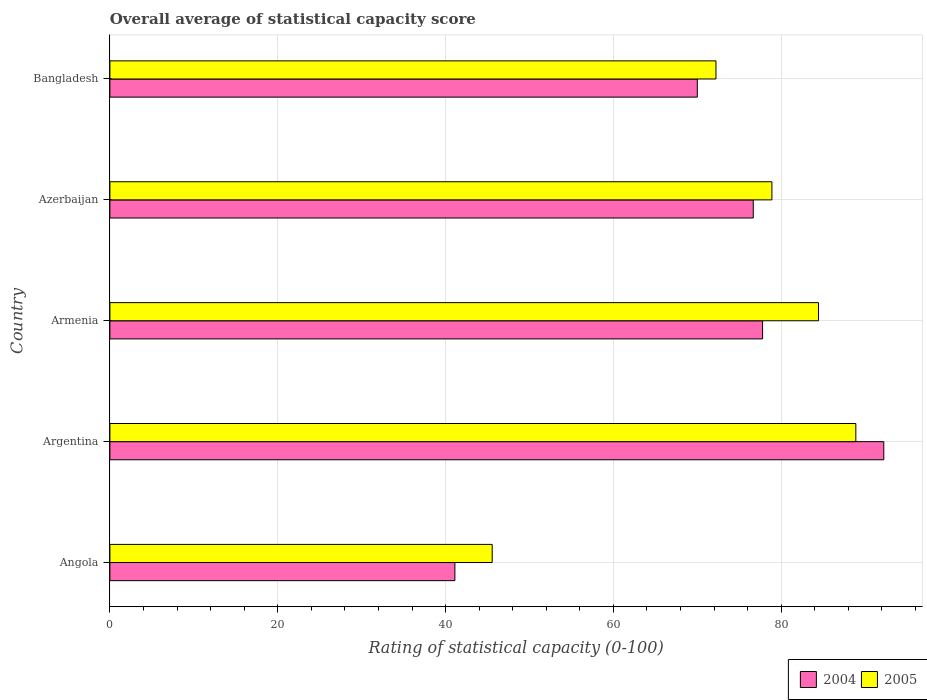How many different coloured bars are there?
Your answer should be compact. 2. How many groups of bars are there?
Your answer should be compact. 5. How many bars are there on the 5th tick from the top?
Ensure brevity in your answer.  2. What is the label of the 2nd group of bars from the top?
Offer a very short reply. Azerbaijan. What is the rating of statistical capacity in 2005 in Bangladesh?
Give a very brief answer. 72.22. Across all countries, what is the maximum rating of statistical capacity in 2005?
Provide a succinct answer. 88.89. Across all countries, what is the minimum rating of statistical capacity in 2005?
Your answer should be compact. 45.56. In which country was the rating of statistical capacity in 2005 maximum?
Provide a succinct answer. Argentina. In which country was the rating of statistical capacity in 2004 minimum?
Your answer should be very brief. Angola. What is the total rating of statistical capacity in 2005 in the graph?
Make the answer very short. 370. What is the difference between the rating of statistical capacity in 2005 in Argentina and that in Azerbaijan?
Make the answer very short. 10. What is the difference between the rating of statistical capacity in 2004 in Bangladesh and the rating of statistical capacity in 2005 in Argentina?
Your answer should be compact. -18.89. What is the difference between the rating of statistical capacity in 2005 and rating of statistical capacity in 2004 in Armenia?
Your response must be concise. 6.67. What is the ratio of the rating of statistical capacity in 2004 in Angola to that in Azerbaijan?
Provide a short and direct response. 0.54. Is the rating of statistical capacity in 2005 in Armenia less than that in Bangladesh?
Provide a succinct answer. No. What is the difference between the highest and the second highest rating of statistical capacity in 2004?
Provide a short and direct response. 14.44. What is the difference between the highest and the lowest rating of statistical capacity in 2004?
Make the answer very short. 51.11. Is the sum of the rating of statistical capacity in 2004 in Angola and Argentina greater than the maximum rating of statistical capacity in 2005 across all countries?
Offer a terse response. Yes. How many bars are there?
Provide a succinct answer. 10. Does the graph contain any zero values?
Keep it short and to the point. No. Does the graph contain grids?
Your answer should be very brief. Yes. How many legend labels are there?
Give a very brief answer. 2. How are the legend labels stacked?
Provide a succinct answer. Horizontal. What is the title of the graph?
Keep it short and to the point. Overall average of statistical capacity score. Does "1963" appear as one of the legend labels in the graph?
Make the answer very short. No. What is the label or title of the X-axis?
Offer a terse response. Rating of statistical capacity (0-100). What is the label or title of the Y-axis?
Make the answer very short. Country. What is the Rating of statistical capacity (0-100) of 2004 in Angola?
Offer a very short reply. 41.11. What is the Rating of statistical capacity (0-100) of 2005 in Angola?
Provide a short and direct response. 45.56. What is the Rating of statistical capacity (0-100) of 2004 in Argentina?
Offer a terse response. 92.22. What is the Rating of statistical capacity (0-100) in 2005 in Argentina?
Provide a succinct answer. 88.89. What is the Rating of statistical capacity (0-100) of 2004 in Armenia?
Give a very brief answer. 77.78. What is the Rating of statistical capacity (0-100) of 2005 in Armenia?
Ensure brevity in your answer.  84.44. What is the Rating of statistical capacity (0-100) of 2004 in Azerbaijan?
Your answer should be compact. 76.67. What is the Rating of statistical capacity (0-100) in 2005 in Azerbaijan?
Your response must be concise. 78.89. What is the Rating of statistical capacity (0-100) of 2005 in Bangladesh?
Your response must be concise. 72.22. Across all countries, what is the maximum Rating of statistical capacity (0-100) in 2004?
Provide a short and direct response. 92.22. Across all countries, what is the maximum Rating of statistical capacity (0-100) of 2005?
Your answer should be compact. 88.89. Across all countries, what is the minimum Rating of statistical capacity (0-100) in 2004?
Your answer should be compact. 41.11. Across all countries, what is the minimum Rating of statistical capacity (0-100) of 2005?
Provide a succinct answer. 45.56. What is the total Rating of statistical capacity (0-100) of 2004 in the graph?
Make the answer very short. 357.78. What is the total Rating of statistical capacity (0-100) in 2005 in the graph?
Provide a short and direct response. 370. What is the difference between the Rating of statistical capacity (0-100) of 2004 in Angola and that in Argentina?
Offer a terse response. -51.11. What is the difference between the Rating of statistical capacity (0-100) of 2005 in Angola and that in Argentina?
Make the answer very short. -43.33. What is the difference between the Rating of statistical capacity (0-100) of 2004 in Angola and that in Armenia?
Make the answer very short. -36.67. What is the difference between the Rating of statistical capacity (0-100) in 2005 in Angola and that in Armenia?
Ensure brevity in your answer.  -38.89. What is the difference between the Rating of statistical capacity (0-100) in 2004 in Angola and that in Azerbaijan?
Give a very brief answer. -35.56. What is the difference between the Rating of statistical capacity (0-100) of 2005 in Angola and that in Azerbaijan?
Your answer should be compact. -33.33. What is the difference between the Rating of statistical capacity (0-100) in 2004 in Angola and that in Bangladesh?
Make the answer very short. -28.89. What is the difference between the Rating of statistical capacity (0-100) in 2005 in Angola and that in Bangladesh?
Provide a short and direct response. -26.67. What is the difference between the Rating of statistical capacity (0-100) of 2004 in Argentina and that in Armenia?
Provide a short and direct response. 14.44. What is the difference between the Rating of statistical capacity (0-100) of 2005 in Argentina and that in Armenia?
Make the answer very short. 4.44. What is the difference between the Rating of statistical capacity (0-100) of 2004 in Argentina and that in Azerbaijan?
Your answer should be compact. 15.56. What is the difference between the Rating of statistical capacity (0-100) of 2005 in Argentina and that in Azerbaijan?
Provide a short and direct response. 10. What is the difference between the Rating of statistical capacity (0-100) of 2004 in Argentina and that in Bangladesh?
Ensure brevity in your answer.  22.22. What is the difference between the Rating of statistical capacity (0-100) in 2005 in Argentina and that in Bangladesh?
Provide a succinct answer. 16.67. What is the difference between the Rating of statistical capacity (0-100) of 2004 in Armenia and that in Azerbaijan?
Give a very brief answer. 1.11. What is the difference between the Rating of statistical capacity (0-100) in 2005 in Armenia and that in Azerbaijan?
Ensure brevity in your answer.  5.56. What is the difference between the Rating of statistical capacity (0-100) of 2004 in Armenia and that in Bangladesh?
Give a very brief answer. 7.78. What is the difference between the Rating of statistical capacity (0-100) in 2005 in Armenia and that in Bangladesh?
Provide a short and direct response. 12.22. What is the difference between the Rating of statistical capacity (0-100) of 2005 in Azerbaijan and that in Bangladesh?
Your answer should be very brief. 6.67. What is the difference between the Rating of statistical capacity (0-100) of 2004 in Angola and the Rating of statistical capacity (0-100) of 2005 in Argentina?
Your response must be concise. -47.78. What is the difference between the Rating of statistical capacity (0-100) in 2004 in Angola and the Rating of statistical capacity (0-100) in 2005 in Armenia?
Your answer should be very brief. -43.33. What is the difference between the Rating of statistical capacity (0-100) in 2004 in Angola and the Rating of statistical capacity (0-100) in 2005 in Azerbaijan?
Your answer should be very brief. -37.78. What is the difference between the Rating of statistical capacity (0-100) of 2004 in Angola and the Rating of statistical capacity (0-100) of 2005 in Bangladesh?
Offer a very short reply. -31.11. What is the difference between the Rating of statistical capacity (0-100) in 2004 in Argentina and the Rating of statistical capacity (0-100) in 2005 in Armenia?
Your response must be concise. 7.78. What is the difference between the Rating of statistical capacity (0-100) in 2004 in Argentina and the Rating of statistical capacity (0-100) in 2005 in Azerbaijan?
Your response must be concise. 13.33. What is the difference between the Rating of statistical capacity (0-100) of 2004 in Argentina and the Rating of statistical capacity (0-100) of 2005 in Bangladesh?
Offer a very short reply. 20. What is the difference between the Rating of statistical capacity (0-100) in 2004 in Armenia and the Rating of statistical capacity (0-100) in 2005 in Azerbaijan?
Give a very brief answer. -1.11. What is the difference between the Rating of statistical capacity (0-100) of 2004 in Armenia and the Rating of statistical capacity (0-100) of 2005 in Bangladesh?
Your answer should be very brief. 5.56. What is the difference between the Rating of statistical capacity (0-100) of 2004 in Azerbaijan and the Rating of statistical capacity (0-100) of 2005 in Bangladesh?
Provide a short and direct response. 4.44. What is the average Rating of statistical capacity (0-100) of 2004 per country?
Your answer should be compact. 71.56. What is the difference between the Rating of statistical capacity (0-100) of 2004 and Rating of statistical capacity (0-100) of 2005 in Angola?
Provide a short and direct response. -4.44. What is the difference between the Rating of statistical capacity (0-100) of 2004 and Rating of statistical capacity (0-100) of 2005 in Armenia?
Give a very brief answer. -6.67. What is the difference between the Rating of statistical capacity (0-100) of 2004 and Rating of statistical capacity (0-100) of 2005 in Azerbaijan?
Provide a short and direct response. -2.22. What is the difference between the Rating of statistical capacity (0-100) in 2004 and Rating of statistical capacity (0-100) in 2005 in Bangladesh?
Offer a terse response. -2.22. What is the ratio of the Rating of statistical capacity (0-100) of 2004 in Angola to that in Argentina?
Make the answer very short. 0.45. What is the ratio of the Rating of statistical capacity (0-100) of 2005 in Angola to that in Argentina?
Keep it short and to the point. 0.51. What is the ratio of the Rating of statistical capacity (0-100) in 2004 in Angola to that in Armenia?
Offer a very short reply. 0.53. What is the ratio of the Rating of statistical capacity (0-100) of 2005 in Angola to that in Armenia?
Ensure brevity in your answer.  0.54. What is the ratio of the Rating of statistical capacity (0-100) of 2004 in Angola to that in Azerbaijan?
Offer a very short reply. 0.54. What is the ratio of the Rating of statistical capacity (0-100) in 2005 in Angola to that in Azerbaijan?
Offer a terse response. 0.58. What is the ratio of the Rating of statistical capacity (0-100) in 2004 in Angola to that in Bangladesh?
Keep it short and to the point. 0.59. What is the ratio of the Rating of statistical capacity (0-100) in 2005 in Angola to that in Bangladesh?
Give a very brief answer. 0.63. What is the ratio of the Rating of statistical capacity (0-100) of 2004 in Argentina to that in Armenia?
Your answer should be very brief. 1.19. What is the ratio of the Rating of statistical capacity (0-100) in 2005 in Argentina to that in Armenia?
Ensure brevity in your answer.  1.05. What is the ratio of the Rating of statistical capacity (0-100) of 2004 in Argentina to that in Azerbaijan?
Offer a very short reply. 1.2. What is the ratio of the Rating of statistical capacity (0-100) in 2005 in Argentina to that in Azerbaijan?
Ensure brevity in your answer.  1.13. What is the ratio of the Rating of statistical capacity (0-100) in 2004 in Argentina to that in Bangladesh?
Your answer should be compact. 1.32. What is the ratio of the Rating of statistical capacity (0-100) in 2005 in Argentina to that in Bangladesh?
Offer a very short reply. 1.23. What is the ratio of the Rating of statistical capacity (0-100) in 2004 in Armenia to that in Azerbaijan?
Keep it short and to the point. 1.01. What is the ratio of the Rating of statistical capacity (0-100) in 2005 in Armenia to that in Azerbaijan?
Ensure brevity in your answer.  1.07. What is the ratio of the Rating of statistical capacity (0-100) in 2005 in Armenia to that in Bangladesh?
Ensure brevity in your answer.  1.17. What is the ratio of the Rating of statistical capacity (0-100) in 2004 in Azerbaijan to that in Bangladesh?
Offer a terse response. 1.1. What is the ratio of the Rating of statistical capacity (0-100) in 2005 in Azerbaijan to that in Bangladesh?
Provide a succinct answer. 1.09. What is the difference between the highest and the second highest Rating of statistical capacity (0-100) of 2004?
Give a very brief answer. 14.44. What is the difference between the highest and the second highest Rating of statistical capacity (0-100) of 2005?
Ensure brevity in your answer.  4.44. What is the difference between the highest and the lowest Rating of statistical capacity (0-100) in 2004?
Make the answer very short. 51.11. What is the difference between the highest and the lowest Rating of statistical capacity (0-100) in 2005?
Provide a short and direct response. 43.33. 